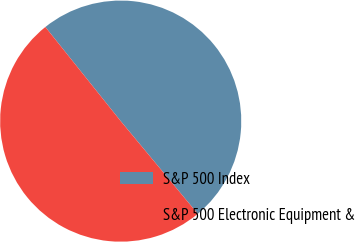<chart> <loc_0><loc_0><loc_500><loc_500><pie_chart><fcel>S&P 500 Index<fcel>S&P 500 Electronic Equipment &<nl><fcel>49.71%<fcel>50.29%<nl></chart> 